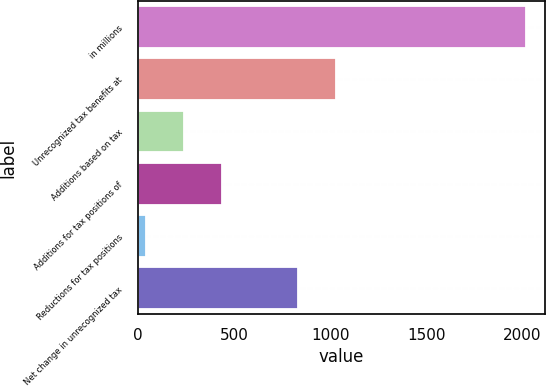<chart> <loc_0><loc_0><loc_500><loc_500><bar_chart><fcel>in millions<fcel>Unrecognized tax benefits at<fcel>Additions based on tax<fcel>Additions for tax positions of<fcel>Reductions for tax positions<fcel>Net change in unrecognized tax<nl><fcel>2017<fcel>1030.5<fcel>241.3<fcel>438.6<fcel>44<fcel>833.2<nl></chart> 